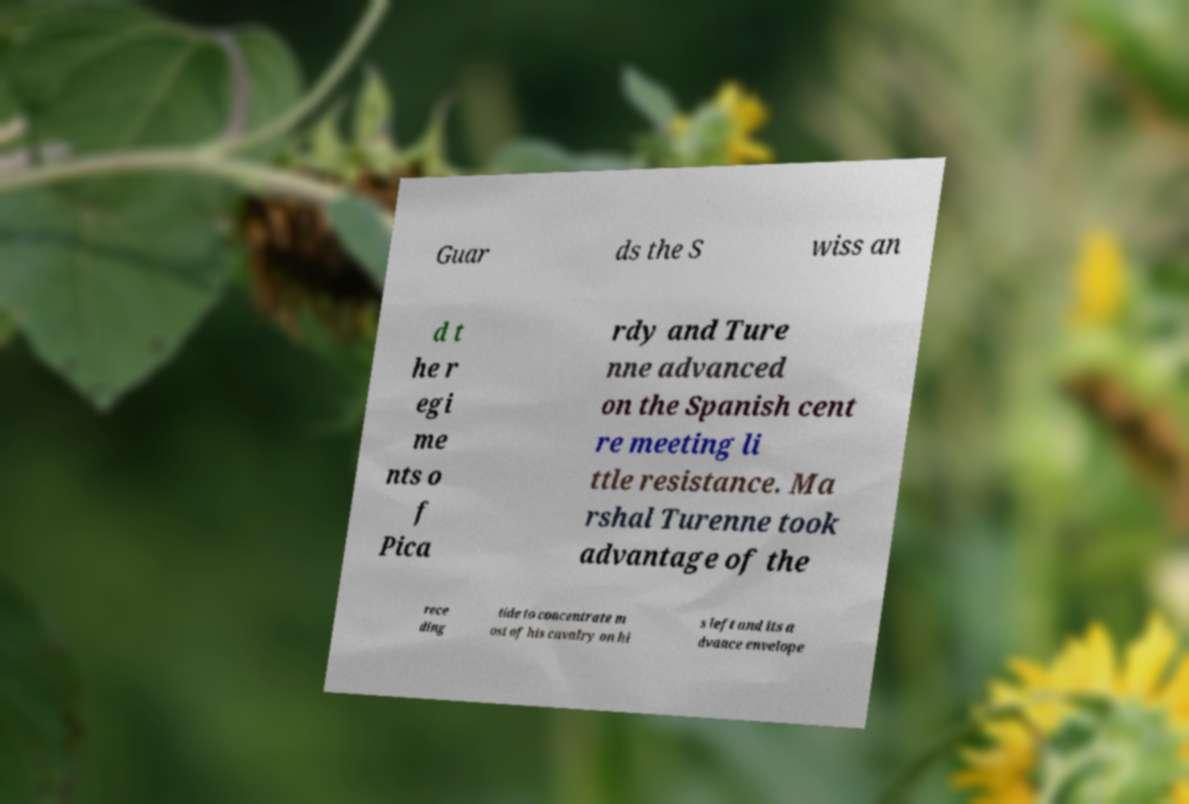There's text embedded in this image that I need extracted. Can you transcribe it verbatim? Guar ds the S wiss an d t he r egi me nts o f Pica rdy and Ture nne advanced on the Spanish cent re meeting li ttle resistance. Ma rshal Turenne took advantage of the rece ding tide to concentrate m ost of his cavalry on hi s left and its a dvance envelope 